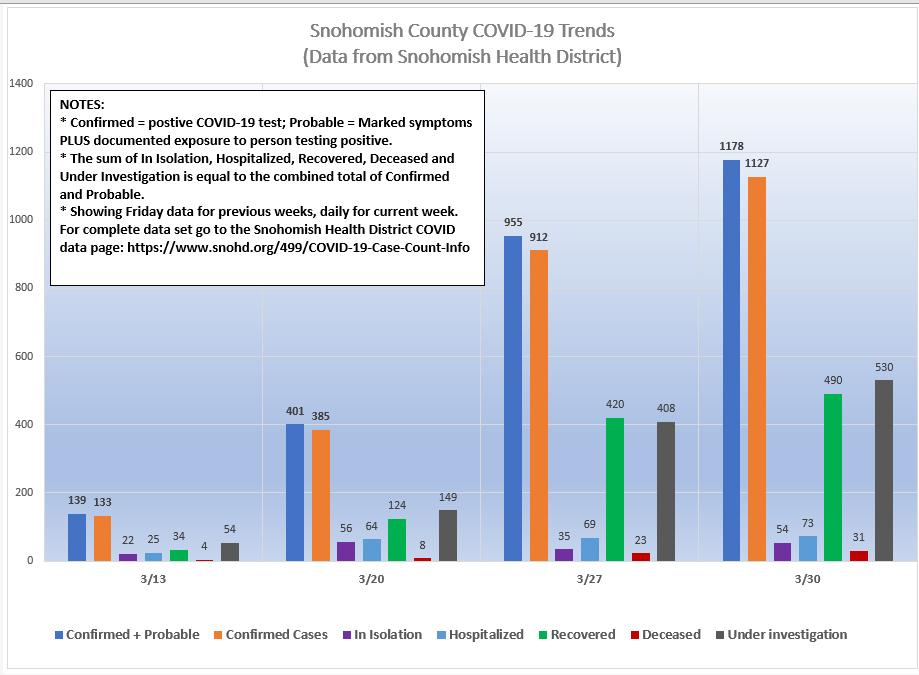Highlight a few significant elements in this photo. As of 3/27, the confirmed number of cases was 912. On March 13th, the number of deceased was at its lowest point. On March 13th, the number of confirmed cases was at its lowest point. On March 30, the number of confirmed cases crossed 1000. On March 20th, the highest number of people were in isolation. 